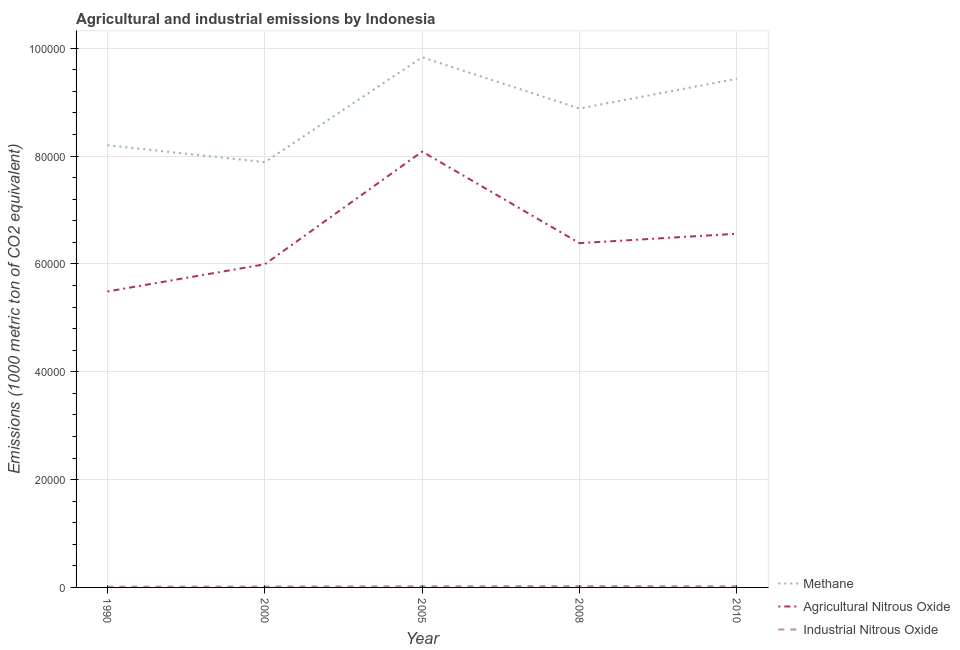How many different coloured lines are there?
Your answer should be very brief. 3. What is the amount of methane emissions in 2010?
Your response must be concise. 9.43e+04. Across all years, what is the maximum amount of methane emissions?
Make the answer very short. 9.83e+04. Across all years, what is the minimum amount of agricultural nitrous oxide emissions?
Offer a very short reply. 5.49e+04. In which year was the amount of methane emissions maximum?
Offer a very short reply. 2005. In which year was the amount of methane emissions minimum?
Ensure brevity in your answer.  2000. What is the total amount of industrial nitrous oxide emissions in the graph?
Your response must be concise. 996.8. What is the difference between the amount of agricultural nitrous oxide emissions in 2000 and that in 2008?
Provide a succinct answer. -3918.1. What is the difference between the amount of agricultural nitrous oxide emissions in 2005 and the amount of industrial nitrous oxide emissions in 2000?
Offer a very short reply. 8.07e+04. What is the average amount of industrial nitrous oxide emissions per year?
Provide a succinct answer. 199.36. In the year 1990, what is the difference between the amount of agricultural nitrous oxide emissions and amount of methane emissions?
Give a very brief answer. -2.71e+04. In how many years, is the amount of agricultural nitrous oxide emissions greater than 24000 metric ton?
Provide a short and direct response. 5. What is the ratio of the amount of industrial nitrous oxide emissions in 2005 to that in 2010?
Offer a very short reply. 1. Is the difference between the amount of methane emissions in 1990 and 2008 greater than the difference between the amount of industrial nitrous oxide emissions in 1990 and 2008?
Give a very brief answer. No. What is the difference between the highest and the second highest amount of methane emissions?
Your answer should be compact. 3987.2. What is the difference between the highest and the lowest amount of agricultural nitrous oxide emissions?
Keep it short and to the point. 2.59e+04. In how many years, is the amount of agricultural nitrous oxide emissions greater than the average amount of agricultural nitrous oxide emissions taken over all years?
Offer a terse response. 2. Is it the case that in every year, the sum of the amount of methane emissions and amount of agricultural nitrous oxide emissions is greater than the amount of industrial nitrous oxide emissions?
Keep it short and to the point. Yes. Does the amount of industrial nitrous oxide emissions monotonically increase over the years?
Make the answer very short. No. How many years are there in the graph?
Provide a succinct answer. 5. What is the difference between two consecutive major ticks on the Y-axis?
Give a very brief answer. 2.00e+04. Are the values on the major ticks of Y-axis written in scientific E-notation?
Ensure brevity in your answer.  No. Where does the legend appear in the graph?
Ensure brevity in your answer.  Bottom right. How many legend labels are there?
Make the answer very short. 3. How are the legend labels stacked?
Make the answer very short. Vertical. What is the title of the graph?
Your response must be concise. Agricultural and industrial emissions by Indonesia. Does "Ores and metals" appear as one of the legend labels in the graph?
Provide a succinct answer. No. What is the label or title of the X-axis?
Offer a very short reply. Year. What is the label or title of the Y-axis?
Provide a succinct answer. Emissions (1000 metric ton of CO2 equivalent). What is the Emissions (1000 metric ton of CO2 equivalent) in Methane in 1990?
Your answer should be very brief. 8.20e+04. What is the Emissions (1000 metric ton of CO2 equivalent) of Agricultural Nitrous Oxide in 1990?
Keep it short and to the point. 5.49e+04. What is the Emissions (1000 metric ton of CO2 equivalent) of Industrial Nitrous Oxide in 1990?
Make the answer very short. 139.5. What is the Emissions (1000 metric ton of CO2 equivalent) of Methane in 2000?
Offer a terse response. 7.89e+04. What is the Emissions (1000 metric ton of CO2 equivalent) in Agricultural Nitrous Oxide in 2000?
Ensure brevity in your answer.  5.99e+04. What is the Emissions (1000 metric ton of CO2 equivalent) of Industrial Nitrous Oxide in 2000?
Provide a succinct answer. 175.8. What is the Emissions (1000 metric ton of CO2 equivalent) of Methane in 2005?
Your answer should be compact. 9.83e+04. What is the Emissions (1000 metric ton of CO2 equivalent) of Agricultural Nitrous Oxide in 2005?
Offer a terse response. 8.08e+04. What is the Emissions (1000 metric ton of CO2 equivalent) of Industrial Nitrous Oxide in 2005?
Ensure brevity in your answer.  219.6. What is the Emissions (1000 metric ton of CO2 equivalent) of Methane in 2008?
Keep it short and to the point. 8.88e+04. What is the Emissions (1000 metric ton of CO2 equivalent) of Agricultural Nitrous Oxide in 2008?
Your answer should be very brief. 6.38e+04. What is the Emissions (1000 metric ton of CO2 equivalent) in Industrial Nitrous Oxide in 2008?
Ensure brevity in your answer.  243.3. What is the Emissions (1000 metric ton of CO2 equivalent) of Methane in 2010?
Your answer should be very brief. 9.43e+04. What is the Emissions (1000 metric ton of CO2 equivalent) of Agricultural Nitrous Oxide in 2010?
Your response must be concise. 6.56e+04. What is the Emissions (1000 metric ton of CO2 equivalent) of Industrial Nitrous Oxide in 2010?
Your answer should be compact. 218.6. Across all years, what is the maximum Emissions (1000 metric ton of CO2 equivalent) of Methane?
Ensure brevity in your answer.  9.83e+04. Across all years, what is the maximum Emissions (1000 metric ton of CO2 equivalent) of Agricultural Nitrous Oxide?
Offer a very short reply. 8.08e+04. Across all years, what is the maximum Emissions (1000 metric ton of CO2 equivalent) in Industrial Nitrous Oxide?
Provide a succinct answer. 243.3. Across all years, what is the minimum Emissions (1000 metric ton of CO2 equivalent) in Methane?
Make the answer very short. 7.89e+04. Across all years, what is the minimum Emissions (1000 metric ton of CO2 equivalent) of Agricultural Nitrous Oxide?
Your response must be concise. 5.49e+04. Across all years, what is the minimum Emissions (1000 metric ton of CO2 equivalent) of Industrial Nitrous Oxide?
Make the answer very short. 139.5. What is the total Emissions (1000 metric ton of CO2 equivalent) of Methane in the graph?
Keep it short and to the point. 4.42e+05. What is the total Emissions (1000 metric ton of CO2 equivalent) in Agricultural Nitrous Oxide in the graph?
Provide a succinct answer. 3.25e+05. What is the total Emissions (1000 metric ton of CO2 equivalent) in Industrial Nitrous Oxide in the graph?
Give a very brief answer. 996.8. What is the difference between the Emissions (1000 metric ton of CO2 equivalent) of Methane in 1990 and that in 2000?
Your answer should be compact. 3136.2. What is the difference between the Emissions (1000 metric ton of CO2 equivalent) of Agricultural Nitrous Oxide in 1990 and that in 2000?
Your answer should be compact. -5044.7. What is the difference between the Emissions (1000 metric ton of CO2 equivalent) of Industrial Nitrous Oxide in 1990 and that in 2000?
Provide a short and direct response. -36.3. What is the difference between the Emissions (1000 metric ton of CO2 equivalent) in Methane in 1990 and that in 2005?
Ensure brevity in your answer.  -1.63e+04. What is the difference between the Emissions (1000 metric ton of CO2 equivalent) of Agricultural Nitrous Oxide in 1990 and that in 2005?
Provide a short and direct response. -2.59e+04. What is the difference between the Emissions (1000 metric ton of CO2 equivalent) in Industrial Nitrous Oxide in 1990 and that in 2005?
Your answer should be very brief. -80.1. What is the difference between the Emissions (1000 metric ton of CO2 equivalent) of Methane in 1990 and that in 2008?
Keep it short and to the point. -6814.3. What is the difference between the Emissions (1000 metric ton of CO2 equivalent) in Agricultural Nitrous Oxide in 1990 and that in 2008?
Offer a very short reply. -8962.8. What is the difference between the Emissions (1000 metric ton of CO2 equivalent) in Industrial Nitrous Oxide in 1990 and that in 2008?
Your answer should be very brief. -103.8. What is the difference between the Emissions (1000 metric ton of CO2 equivalent) in Methane in 1990 and that in 2010?
Your answer should be compact. -1.23e+04. What is the difference between the Emissions (1000 metric ton of CO2 equivalent) of Agricultural Nitrous Oxide in 1990 and that in 2010?
Keep it short and to the point. -1.07e+04. What is the difference between the Emissions (1000 metric ton of CO2 equivalent) of Industrial Nitrous Oxide in 1990 and that in 2010?
Your response must be concise. -79.1. What is the difference between the Emissions (1000 metric ton of CO2 equivalent) in Methane in 2000 and that in 2005?
Keep it short and to the point. -1.94e+04. What is the difference between the Emissions (1000 metric ton of CO2 equivalent) in Agricultural Nitrous Oxide in 2000 and that in 2005?
Offer a very short reply. -2.09e+04. What is the difference between the Emissions (1000 metric ton of CO2 equivalent) in Industrial Nitrous Oxide in 2000 and that in 2005?
Give a very brief answer. -43.8. What is the difference between the Emissions (1000 metric ton of CO2 equivalent) in Methane in 2000 and that in 2008?
Your answer should be very brief. -9950.5. What is the difference between the Emissions (1000 metric ton of CO2 equivalent) in Agricultural Nitrous Oxide in 2000 and that in 2008?
Your answer should be compact. -3918.1. What is the difference between the Emissions (1000 metric ton of CO2 equivalent) of Industrial Nitrous Oxide in 2000 and that in 2008?
Offer a terse response. -67.5. What is the difference between the Emissions (1000 metric ton of CO2 equivalent) of Methane in 2000 and that in 2010?
Offer a terse response. -1.55e+04. What is the difference between the Emissions (1000 metric ton of CO2 equivalent) of Agricultural Nitrous Oxide in 2000 and that in 2010?
Keep it short and to the point. -5659.3. What is the difference between the Emissions (1000 metric ton of CO2 equivalent) in Industrial Nitrous Oxide in 2000 and that in 2010?
Give a very brief answer. -42.8. What is the difference between the Emissions (1000 metric ton of CO2 equivalent) in Methane in 2005 and that in 2008?
Provide a succinct answer. 9496.1. What is the difference between the Emissions (1000 metric ton of CO2 equivalent) of Agricultural Nitrous Oxide in 2005 and that in 2008?
Offer a very short reply. 1.70e+04. What is the difference between the Emissions (1000 metric ton of CO2 equivalent) in Industrial Nitrous Oxide in 2005 and that in 2008?
Provide a succinct answer. -23.7. What is the difference between the Emissions (1000 metric ton of CO2 equivalent) of Methane in 2005 and that in 2010?
Your answer should be very brief. 3987.2. What is the difference between the Emissions (1000 metric ton of CO2 equivalent) in Agricultural Nitrous Oxide in 2005 and that in 2010?
Offer a very short reply. 1.52e+04. What is the difference between the Emissions (1000 metric ton of CO2 equivalent) in Methane in 2008 and that in 2010?
Make the answer very short. -5508.9. What is the difference between the Emissions (1000 metric ton of CO2 equivalent) of Agricultural Nitrous Oxide in 2008 and that in 2010?
Offer a terse response. -1741.2. What is the difference between the Emissions (1000 metric ton of CO2 equivalent) in Industrial Nitrous Oxide in 2008 and that in 2010?
Your response must be concise. 24.7. What is the difference between the Emissions (1000 metric ton of CO2 equivalent) of Methane in 1990 and the Emissions (1000 metric ton of CO2 equivalent) of Agricultural Nitrous Oxide in 2000?
Provide a short and direct response. 2.21e+04. What is the difference between the Emissions (1000 metric ton of CO2 equivalent) in Methane in 1990 and the Emissions (1000 metric ton of CO2 equivalent) in Industrial Nitrous Oxide in 2000?
Your answer should be very brief. 8.18e+04. What is the difference between the Emissions (1000 metric ton of CO2 equivalent) in Agricultural Nitrous Oxide in 1990 and the Emissions (1000 metric ton of CO2 equivalent) in Industrial Nitrous Oxide in 2000?
Offer a terse response. 5.47e+04. What is the difference between the Emissions (1000 metric ton of CO2 equivalent) in Methane in 1990 and the Emissions (1000 metric ton of CO2 equivalent) in Agricultural Nitrous Oxide in 2005?
Keep it short and to the point. 1171.4. What is the difference between the Emissions (1000 metric ton of CO2 equivalent) in Methane in 1990 and the Emissions (1000 metric ton of CO2 equivalent) in Industrial Nitrous Oxide in 2005?
Offer a terse response. 8.18e+04. What is the difference between the Emissions (1000 metric ton of CO2 equivalent) in Agricultural Nitrous Oxide in 1990 and the Emissions (1000 metric ton of CO2 equivalent) in Industrial Nitrous Oxide in 2005?
Ensure brevity in your answer.  5.47e+04. What is the difference between the Emissions (1000 metric ton of CO2 equivalent) in Methane in 1990 and the Emissions (1000 metric ton of CO2 equivalent) in Agricultural Nitrous Oxide in 2008?
Keep it short and to the point. 1.82e+04. What is the difference between the Emissions (1000 metric ton of CO2 equivalent) in Methane in 1990 and the Emissions (1000 metric ton of CO2 equivalent) in Industrial Nitrous Oxide in 2008?
Provide a short and direct response. 8.18e+04. What is the difference between the Emissions (1000 metric ton of CO2 equivalent) in Agricultural Nitrous Oxide in 1990 and the Emissions (1000 metric ton of CO2 equivalent) in Industrial Nitrous Oxide in 2008?
Your response must be concise. 5.46e+04. What is the difference between the Emissions (1000 metric ton of CO2 equivalent) of Methane in 1990 and the Emissions (1000 metric ton of CO2 equivalent) of Agricultural Nitrous Oxide in 2010?
Your answer should be very brief. 1.64e+04. What is the difference between the Emissions (1000 metric ton of CO2 equivalent) in Methane in 1990 and the Emissions (1000 metric ton of CO2 equivalent) in Industrial Nitrous Oxide in 2010?
Your answer should be compact. 8.18e+04. What is the difference between the Emissions (1000 metric ton of CO2 equivalent) of Agricultural Nitrous Oxide in 1990 and the Emissions (1000 metric ton of CO2 equivalent) of Industrial Nitrous Oxide in 2010?
Keep it short and to the point. 5.47e+04. What is the difference between the Emissions (1000 metric ton of CO2 equivalent) of Methane in 2000 and the Emissions (1000 metric ton of CO2 equivalent) of Agricultural Nitrous Oxide in 2005?
Offer a very short reply. -1964.8. What is the difference between the Emissions (1000 metric ton of CO2 equivalent) of Methane in 2000 and the Emissions (1000 metric ton of CO2 equivalent) of Industrial Nitrous Oxide in 2005?
Provide a short and direct response. 7.86e+04. What is the difference between the Emissions (1000 metric ton of CO2 equivalent) in Agricultural Nitrous Oxide in 2000 and the Emissions (1000 metric ton of CO2 equivalent) in Industrial Nitrous Oxide in 2005?
Provide a succinct answer. 5.97e+04. What is the difference between the Emissions (1000 metric ton of CO2 equivalent) in Methane in 2000 and the Emissions (1000 metric ton of CO2 equivalent) in Agricultural Nitrous Oxide in 2008?
Offer a very short reply. 1.50e+04. What is the difference between the Emissions (1000 metric ton of CO2 equivalent) of Methane in 2000 and the Emissions (1000 metric ton of CO2 equivalent) of Industrial Nitrous Oxide in 2008?
Your response must be concise. 7.86e+04. What is the difference between the Emissions (1000 metric ton of CO2 equivalent) in Agricultural Nitrous Oxide in 2000 and the Emissions (1000 metric ton of CO2 equivalent) in Industrial Nitrous Oxide in 2008?
Offer a very short reply. 5.97e+04. What is the difference between the Emissions (1000 metric ton of CO2 equivalent) of Methane in 2000 and the Emissions (1000 metric ton of CO2 equivalent) of Agricultural Nitrous Oxide in 2010?
Provide a succinct answer. 1.33e+04. What is the difference between the Emissions (1000 metric ton of CO2 equivalent) in Methane in 2000 and the Emissions (1000 metric ton of CO2 equivalent) in Industrial Nitrous Oxide in 2010?
Give a very brief answer. 7.86e+04. What is the difference between the Emissions (1000 metric ton of CO2 equivalent) in Agricultural Nitrous Oxide in 2000 and the Emissions (1000 metric ton of CO2 equivalent) in Industrial Nitrous Oxide in 2010?
Keep it short and to the point. 5.97e+04. What is the difference between the Emissions (1000 metric ton of CO2 equivalent) in Methane in 2005 and the Emissions (1000 metric ton of CO2 equivalent) in Agricultural Nitrous Oxide in 2008?
Offer a terse response. 3.45e+04. What is the difference between the Emissions (1000 metric ton of CO2 equivalent) of Methane in 2005 and the Emissions (1000 metric ton of CO2 equivalent) of Industrial Nitrous Oxide in 2008?
Offer a terse response. 9.81e+04. What is the difference between the Emissions (1000 metric ton of CO2 equivalent) in Agricultural Nitrous Oxide in 2005 and the Emissions (1000 metric ton of CO2 equivalent) in Industrial Nitrous Oxide in 2008?
Your answer should be compact. 8.06e+04. What is the difference between the Emissions (1000 metric ton of CO2 equivalent) in Methane in 2005 and the Emissions (1000 metric ton of CO2 equivalent) in Agricultural Nitrous Oxide in 2010?
Give a very brief answer. 3.27e+04. What is the difference between the Emissions (1000 metric ton of CO2 equivalent) of Methane in 2005 and the Emissions (1000 metric ton of CO2 equivalent) of Industrial Nitrous Oxide in 2010?
Offer a very short reply. 9.81e+04. What is the difference between the Emissions (1000 metric ton of CO2 equivalent) in Agricultural Nitrous Oxide in 2005 and the Emissions (1000 metric ton of CO2 equivalent) in Industrial Nitrous Oxide in 2010?
Your response must be concise. 8.06e+04. What is the difference between the Emissions (1000 metric ton of CO2 equivalent) of Methane in 2008 and the Emissions (1000 metric ton of CO2 equivalent) of Agricultural Nitrous Oxide in 2010?
Your answer should be very brief. 2.32e+04. What is the difference between the Emissions (1000 metric ton of CO2 equivalent) in Methane in 2008 and the Emissions (1000 metric ton of CO2 equivalent) in Industrial Nitrous Oxide in 2010?
Keep it short and to the point. 8.86e+04. What is the difference between the Emissions (1000 metric ton of CO2 equivalent) in Agricultural Nitrous Oxide in 2008 and the Emissions (1000 metric ton of CO2 equivalent) in Industrial Nitrous Oxide in 2010?
Your answer should be very brief. 6.36e+04. What is the average Emissions (1000 metric ton of CO2 equivalent) in Methane per year?
Provide a short and direct response. 8.85e+04. What is the average Emissions (1000 metric ton of CO2 equivalent) of Agricultural Nitrous Oxide per year?
Ensure brevity in your answer.  6.50e+04. What is the average Emissions (1000 metric ton of CO2 equivalent) in Industrial Nitrous Oxide per year?
Provide a short and direct response. 199.36. In the year 1990, what is the difference between the Emissions (1000 metric ton of CO2 equivalent) of Methane and Emissions (1000 metric ton of CO2 equivalent) of Agricultural Nitrous Oxide?
Provide a succinct answer. 2.71e+04. In the year 1990, what is the difference between the Emissions (1000 metric ton of CO2 equivalent) of Methane and Emissions (1000 metric ton of CO2 equivalent) of Industrial Nitrous Oxide?
Provide a succinct answer. 8.19e+04. In the year 1990, what is the difference between the Emissions (1000 metric ton of CO2 equivalent) of Agricultural Nitrous Oxide and Emissions (1000 metric ton of CO2 equivalent) of Industrial Nitrous Oxide?
Provide a short and direct response. 5.47e+04. In the year 2000, what is the difference between the Emissions (1000 metric ton of CO2 equivalent) in Methane and Emissions (1000 metric ton of CO2 equivalent) in Agricultural Nitrous Oxide?
Provide a short and direct response. 1.89e+04. In the year 2000, what is the difference between the Emissions (1000 metric ton of CO2 equivalent) of Methane and Emissions (1000 metric ton of CO2 equivalent) of Industrial Nitrous Oxide?
Offer a terse response. 7.87e+04. In the year 2000, what is the difference between the Emissions (1000 metric ton of CO2 equivalent) of Agricultural Nitrous Oxide and Emissions (1000 metric ton of CO2 equivalent) of Industrial Nitrous Oxide?
Give a very brief answer. 5.98e+04. In the year 2005, what is the difference between the Emissions (1000 metric ton of CO2 equivalent) in Methane and Emissions (1000 metric ton of CO2 equivalent) in Agricultural Nitrous Oxide?
Make the answer very short. 1.75e+04. In the year 2005, what is the difference between the Emissions (1000 metric ton of CO2 equivalent) in Methane and Emissions (1000 metric ton of CO2 equivalent) in Industrial Nitrous Oxide?
Keep it short and to the point. 9.81e+04. In the year 2005, what is the difference between the Emissions (1000 metric ton of CO2 equivalent) of Agricultural Nitrous Oxide and Emissions (1000 metric ton of CO2 equivalent) of Industrial Nitrous Oxide?
Make the answer very short. 8.06e+04. In the year 2008, what is the difference between the Emissions (1000 metric ton of CO2 equivalent) of Methane and Emissions (1000 metric ton of CO2 equivalent) of Agricultural Nitrous Oxide?
Offer a terse response. 2.50e+04. In the year 2008, what is the difference between the Emissions (1000 metric ton of CO2 equivalent) in Methane and Emissions (1000 metric ton of CO2 equivalent) in Industrial Nitrous Oxide?
Offer a very short reply. 8.86e+04. In the year 2008, what is the difference between the Emissions (1000 metric ton of CO2 equivalent) in Agricultural Nitrous Oxide and Emissions (1000 metric ton of CO2 equivalent) in Industrial Nitrous Oxide?
Your answer should be compact. 6.36e+04. In the year 2010, what is the difference between the Emissions (1000 metric ton of CO2 equivalent) of Methane and Emissions (1000 metric ton of CO2 equivalent) of Agricultural Nitrous Oxide?
Offer a very short reply. 2.87e+04. In the year 2010, what is the difference between the Emissions (1000 metric ton of CO2 equivalent) of Methane and Emissions (1000 metric ton of CO2 equivalent) of Industrial Nitrous Oxide?
Offer a very short reply. 9.41e+04. In the year 2010, what is the difference between the Emissions (1000 metric ton of CO2 equivalent) of Agricultural Nitrous Oxide and Emissions (1000 metric ton of CO2 equivalent) of Industrial Nitrous Oxide?
Give a very brief answer. 6.54e+04. What is the ratio of the Emissions (1000 metric ton of CO2 equivalent) of Methane in 1990 to that in 2000?
Give a very brief answer. 1.04. What is the ratio of the Emissions (1000 metric ton of CO2 equivalent) of Agricultural Nitrous Oxide in 1990 to that in 2000?
Give a very brief answer. 0.92. What is the ratio of the Emissions (1000 metric ton of CO2 equivalent) in Industrial Nitrous Oxide in 1990 to that in 2000?
Ensure brevity in your answer.  0.79. What is the ratio of the Emissions (1000 metric ton of CO2 equivalent) in Methane in 1990 to that in 2005?
Your answer should be very brief. 0.83. What is the ratio of the Emissions (1000 metric ton of CO2 equivalent) of Agricultural Nitrous Oxide in 1990 to that in 2005?
Provide a short and direct response. 0.68. What is the ratio of the Emissions (1000 metric ton of CO2 equivalent) in Industrial Nitrous Oxide in 1990 to that in 2005?
Your response must be concise. 0.64. What is the ratio of the Emissions (1000 metric ton of CO2 equivalent) of Methane in 1990 to that in 2008?
Your response must be concise. 0.92. What is the ratio of the Emissions (1000 metric ton of CO2 equivalent) in Agricultural Nitrous Oxide in 1990 to that in 2008?
Your answer should be compact. 0.86. What is the ratio of the Emissions (1000 metric ton of CO2 equivalent) of Industrial Nitrous Oxide in 1990 to that in 2008?
Offer a terse response. 0.57. What is the ratio of the Emissions (1000 metric ton of CO2 equivalent) of Methane in 1990 to that in 2010?
Provide a succinct answer. 0.87. What is the ratio of the Emissions (1000 metric ton of CO2 equivalent) of Agricultural Nitrous Oxide in 1990 to that in 2010?
Ensure brevity in your answer.  0.84. What is the ratio of the Emissions (1000 metric ton of CO2 equivalent) in Industrial Nitrous Oxide in 1990 to that in 2010?
Keep it short and to the point. 0.64. What is the ratio of the Emissions (1000 metric ton of CO2 equivalent) of Methane in 2000 to that in 2005?
Provide a succinct answer. 0.8. What is the ratio of the Emissions (1000 metric ton of CO2 equivalent) of Agricultural Nitrous Oxide in 2000 to that in 2005?
Give a very brief answer. 0.74. What is the ratio of the Emissions (1000 metric ton of CO2 equivalent) of Industrial Nitrous Oxide in 2000 to that in 2005?
Ensure brevity in your answer.  0.8. What is the ratio of the Emissions (1000 metric ton of CO2 equivalent) in Methane in 2000 to that in 2008?
Keep it short and to the point. 0.89. What is the ratio of the Emissions (1000 metric ton of CO2 equivalent) in Agricultural Nitrous Oxide in 2000 to that in 2008?
Ensure brevity in your answer.  0.94. What is the ratio of the Emissions (1000 metric ton of CO2 equivalent) of Industrial Nitrous Oxide in 2000 to that in 2008?
Make the answer very short. 0.72. What is the ratio of the Emissions (1000 metric ton of CO2 equivalent) in Methane in 2000 to that in 2010?
Your answer should be very brief. 0.84. What is the ratio of the Emissions (1000 metric ton of CO2 equivalent) of Agricultural Nitrous Oxide in 2000 to that in 2010?
Ensure brevity in your answer.  0.91. What is the ratio of the Emissions (1000 metric ton of CO2 equivalent) in Industrial Nitrous Oxide in 2000 to that in 2010?
Offer a terse response. 0.8. What is the ratio of the Emissions (1000 metric ton of CO2 equivalent) in Methane in 2005 to that in 2008?
Provide a short and direct response. 1.11. What is the ratio of the Emissions (1000 metric ton of CO2 equivalent) in Agricultural Nitrous Oxide in 2005 to that in 2008?
Your answer should be very brief. 1.27. What is the ratio of the Emissions (1000 metric ton of CO2 equivalent) of Industrial Nitrous Oxide in 2005 to that in 2008?
Your answer should be very brief. 0.9. What is the ratio of the Emissions (1000 metric ton of CO2 equivalent) of Methane in 2005 to that in 2010?
Provide a succinct answer. 1.04. What is the ratio of the Emissions (1000 metric ton of CO2 equivalent) in Agricultural Nitrous Oxide in 2005 to that in 2010?
Ensure brevity in your answer.  1.23. What is the ratio of the Emissions (1000 metric ton of CO2 equivalent) in Industrial Nitrous Oxide in 2005 to that in 2010?
Keep it short and to the point. 1. What is the ratio of the Emissions (1000 metric ton of CO2 equivalent) of Methane in 2008 to that in 2010?
Make the answer very short. 0.94. What is the ratio of the Emissions (1000 metric ton of CO2 equivalent) of Agricultural Nitrous Oxide in 2008 to that in 2010?
Provide a succinct answer. 0.97. What is the ratio of the Emissions (1000 metric ton of CO2 equivalent) of Industrial Nitrous Oxide in 2008 to that in 2010?
Offer a very short reply. 1.11. What is the difference between the highest and the second highest Emissions (1000 metric ton of CO2 equivalent) of Methane?
Make the answer very short. 3987.2. What is the difference between the highest and the second highest Emissions (1000 metric ton of CO2 equivalent) in Agricultural Nitrous Oxide?
Your answer should be compact. 1.52e+04. What is the difference between the highest and the second highest Emissions (1000 metric ton of CO2 equivalent) in Industrial Nitrous Oxide?
Keep it short and to the point. 23.7. What is the difference between the highest and the lowest Emissions (1000 metric ton of CO2 equivalent) of Methane?
Make the answer very short. 1.94e+04. What is the difference between the highest and the lowest Emissions (1000 metric ton of CO2 equivalent) in Agricultural Nitrous Oxide?
Your answer should be very brief. 2.59e+04. What is the difference between the highest and the lowest Emissions (1000 metric ton of CO2 equivalent) in Industrial Nitrous Oxide?
Your answer should be compact. 103.8. 